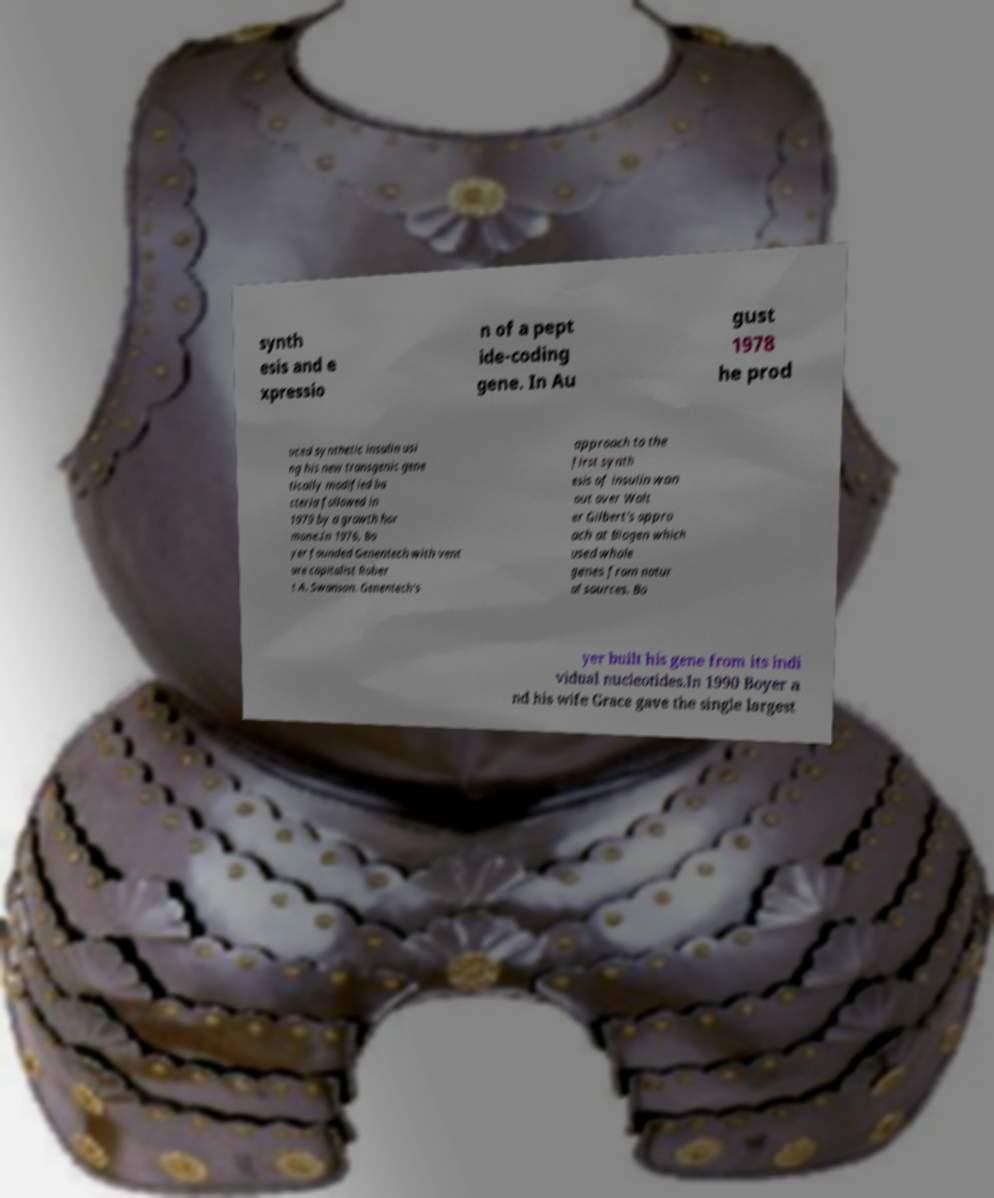For documentation purposes, I need the text within this image transcribed. Could you provide that? synth esis and e xpressio n of a pept ide-coding gene. In Au gust 1978 he prod uced synthetic insulin usi ng his new transgenic gene tically modified ba cteria followed in 1979 by a growth hor mone.In 1976, Bo yer founded Genentech with vent ure capitalist Rober t A. Swanson. Genentech's approach to the first synth esis of insulin won out over Walt er Gilbert's appro ach at Biogen which used whole genes from natur al sources. Bo yer built his gene from its indi vidual nucleotides.In 1990 Boyer a nd his wife Grace gave the single largest 